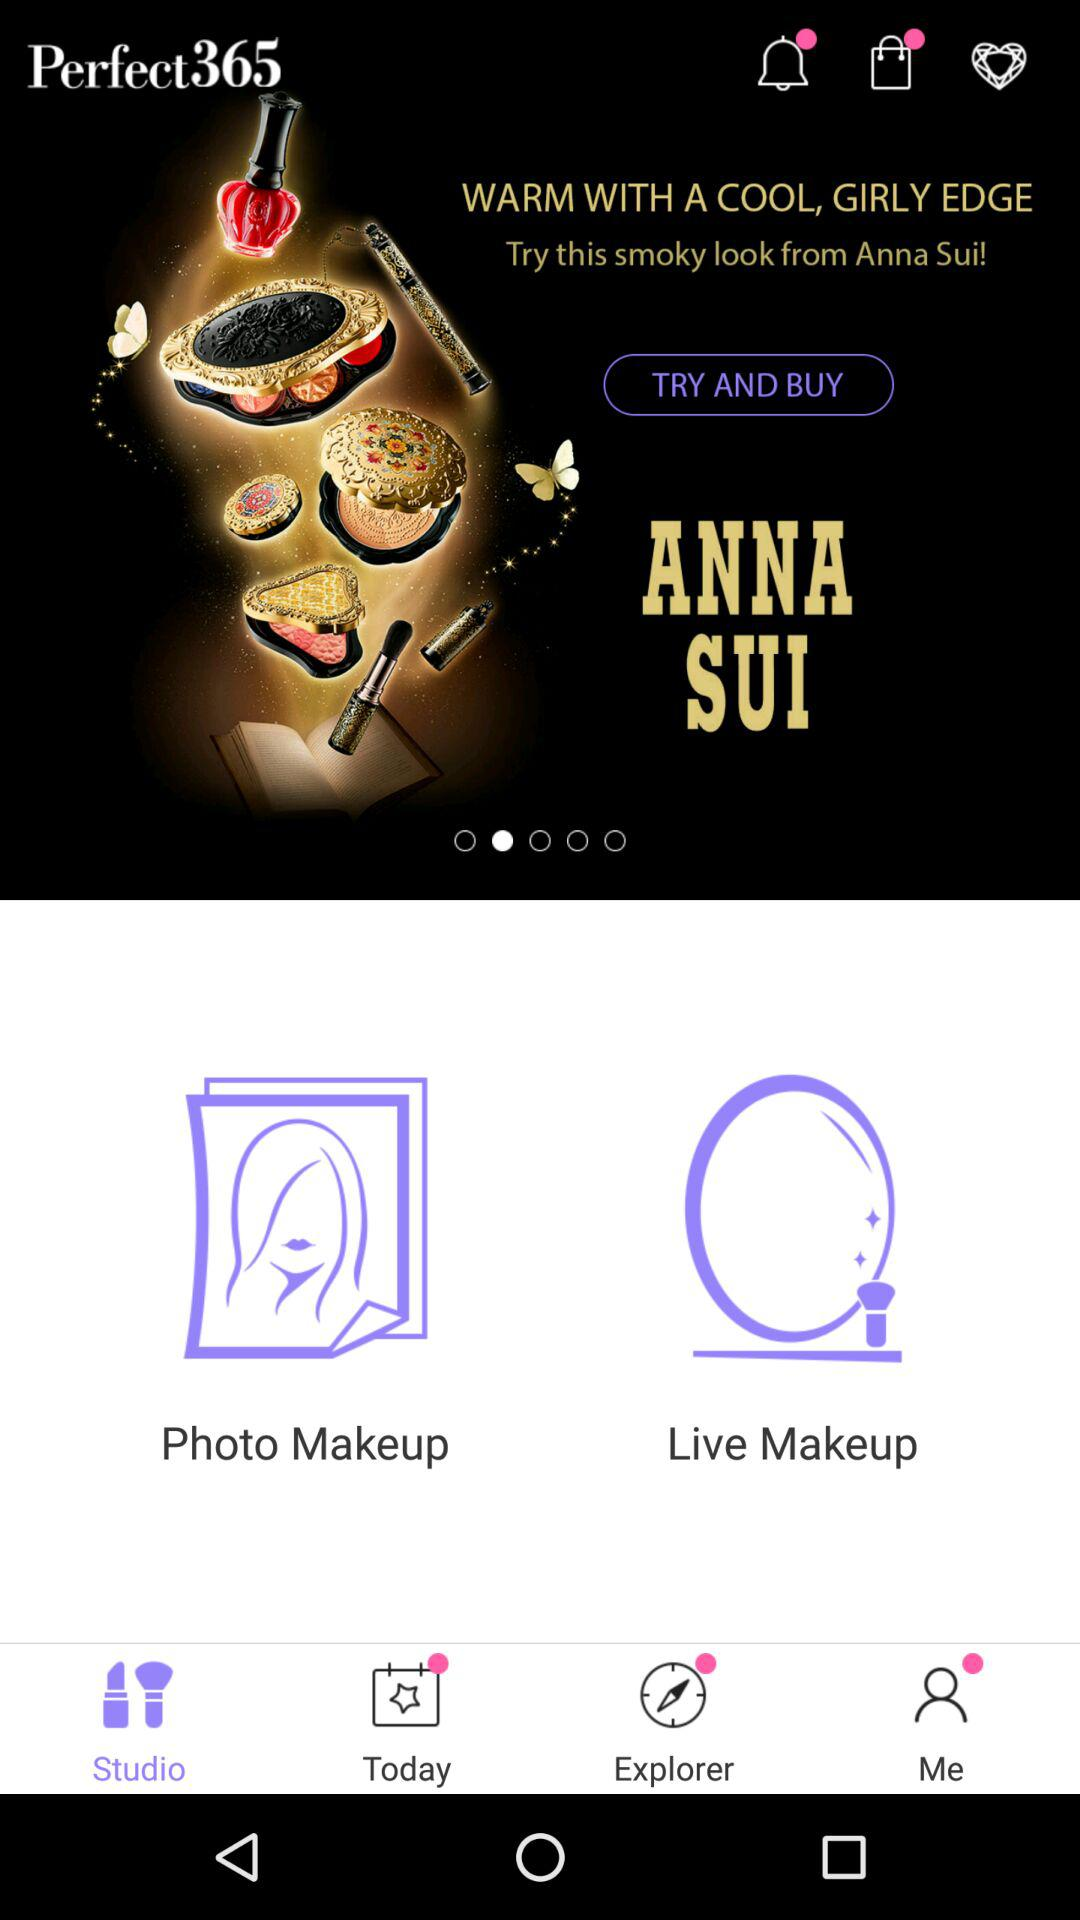Which tab has been selected? The tab that has been selected is "Studio". 